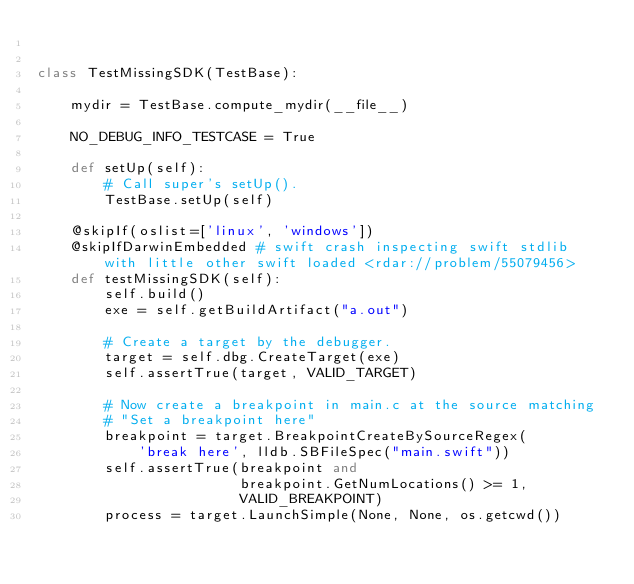Convert code to text. <code><loc_0><loc_0><loc_500><loc_500><_Python_>

class TestMissingSDK(TestBase):

    mydir = TestBase.compute_mydir(__file__)

    NO_DEBUG_INFO_TESTCASE = True

    def setUp(self):
        # Call super's setUp().
        TestBase.setUp(self)

    @skipIf(oslist=['linux', 'windows'])
    @skipIfDarwinEmbedded # swift crash inspecting swift stdlib with little other swift loaded <rdar://problem/55079456> 
    def testMissingSDK(self):
        self.build()
        exe = self.getBuildArtifact("a.out")

        # Create a target by the debugger.
        target = self.dbg.CreateTarget(exe)
        self.assertTrue(target, VALID_TARGET)

        # Now create a breakpoint in main.c at the source matching
        # "Set a breakpoint here"
        breakpoint = target.BreakpointCreateBySourceRegex(
            'break here', lldb.SBFileSpec("main.swift"))
        self.assertTrue(breakpoint and
                        breakpoint.GetNumLocations() >= 1,
                        VALID_BREAKPOINT)
        process = target.LaunchSimple(None, None, os.getcwd())</code> 